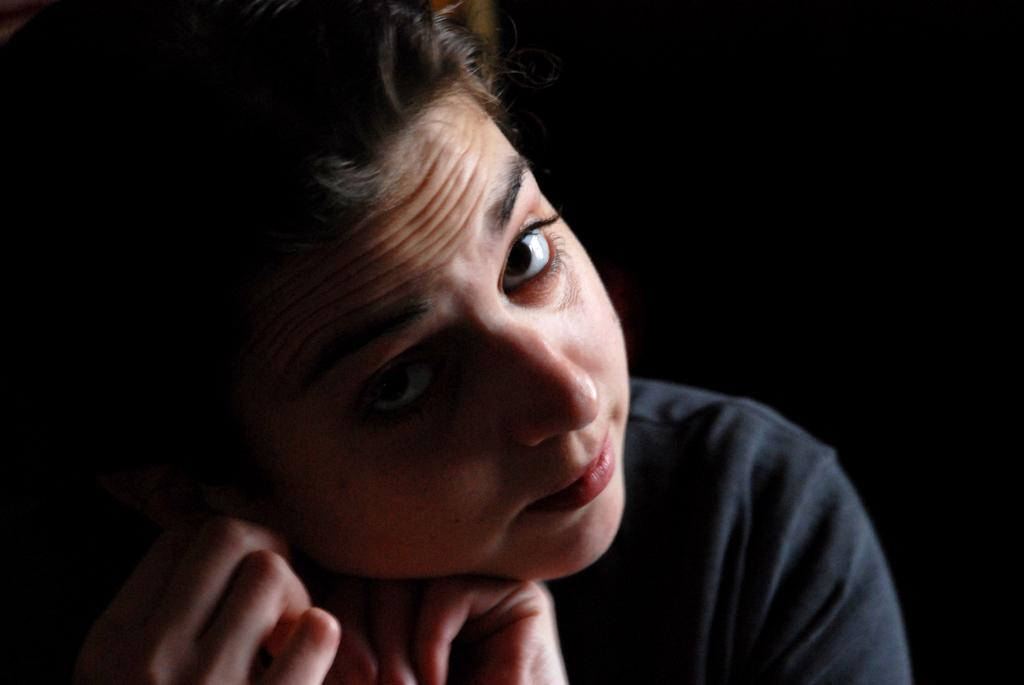What is the main subject in the image? There is a person in the image. What type of wrench is the mother using to put out the fire in the image? There is no mother, wrench, or fire present in the image; it only features a person. 